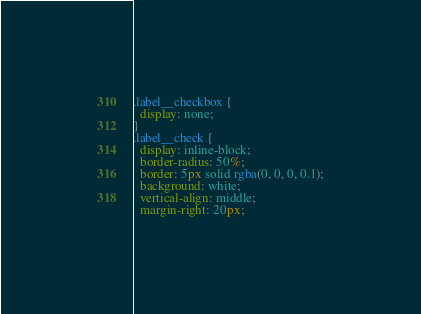<code> <loc_0><loc_0><loc_500><loc_500><_CSS_>.label__checkbox {
  display: none;
}
.label__check {
  display: inline-block;
  border-radius: 50%;
  border: 5px solid rgba(0, 0, 0, 0.1);
  background: white;
  vertical-align: middle;
  margin-right: 20px;</code> 